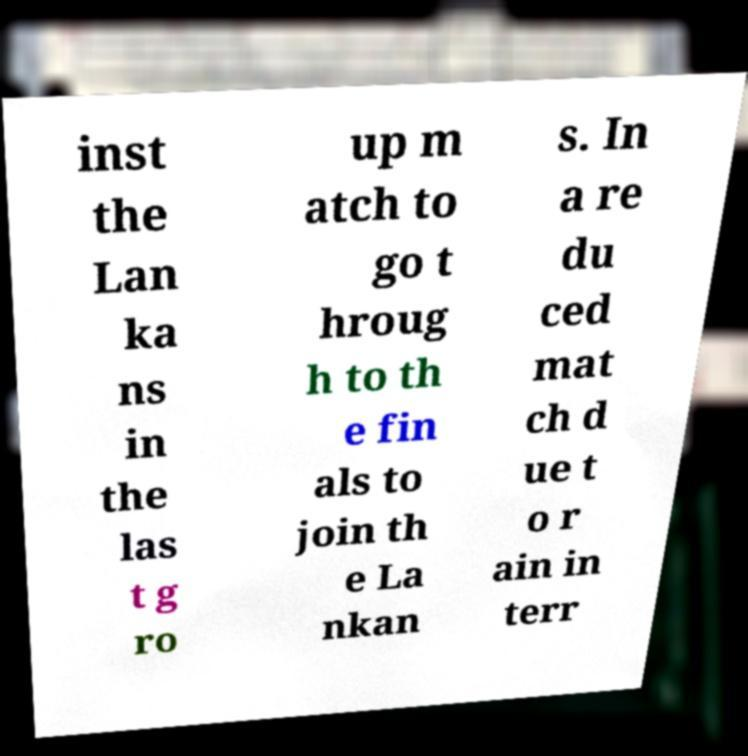Can you accurately transcribe the text from the provided image for me? inst the Lan ka ns in the las t g ro up m atch to go t hroug h to th e fin als to join th e La nkan s. In a re du ced mat ch d ue t o r ain in terr 